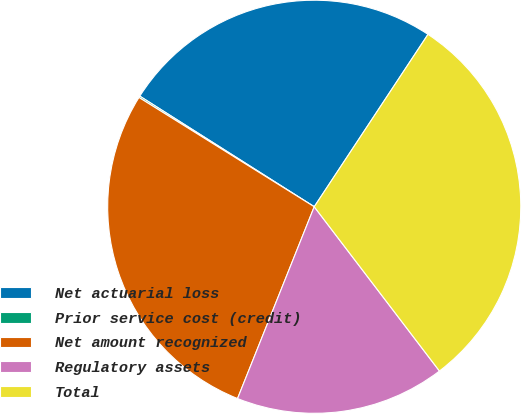Convert chart to OTSL. <chart><loc_0><loc_0><loc_500><loc_500><pie_chart><fcel>Net actuarial loss<fcel>Prior service cost (credit)<fcel>Net amount recognized<fcel>Regulatory assets<fcel>Total<nl><fcel>25.29%<fcel>0.12%<fcel>27.82%<fcel>16.42%<fcel>30.35%<nl></chart> 